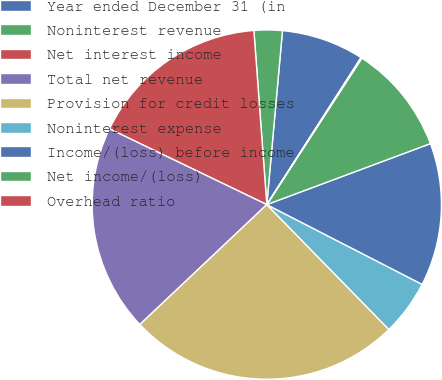Convert chart. <chart><loc_0><loc_0><loc_500><loc_500><pie_chart><fcel>Year ended December 31 (in<fcel>Noninterest revenue<fcel>Net interest income<fcel>Total net revenue<fcel>Provision for credit losses<fcel>Noninterest expense<fcel>Income/(loss) before income<fcel>Net income/(loss)<fcel>Overhead ratio<nl><fcel>7.64%<fcel>2.61%<fcel>16.68%<fcel>19.19%<fcel>25.27%<fcel>5.13%<fcel>13.23%<fcel>10.16%<fcel>0.09%<nl></chart> 